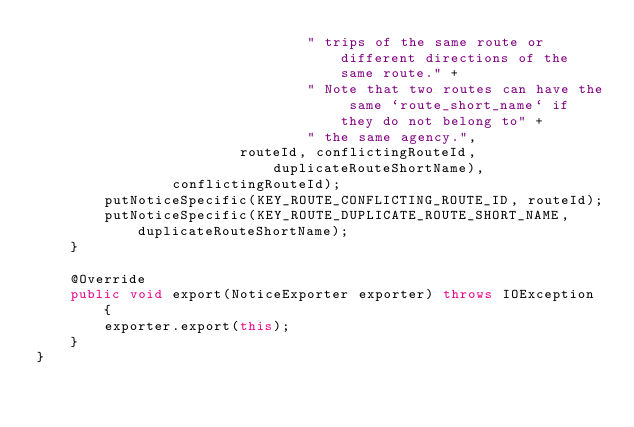Convert code to text. <code><loc_0><loc_0><loc_500><loc_500><_Java_>                                " trips of the same route or different directions of the same route." +
                                " Note that two routes can have the same `route_short_name` if they do not belong to" +
                                " the same agency.",
                        routeId, conflictingRouteId, duplicateRouteShortName),
                conflictingRouteId);
        putNoticeSpecific(KEY_ROUTE_CONFLICTING_ROUTE_ID, routeId);
        putNoticeSpecific(KEY_ROUTE_DUPLICATE_ROUTE_SHORT_NAME, duplicateRouteShortName);
    }

    @Override
    public void export(NoticeExporter exporter) throws IOException {
        exporter.export(this);
    }
}
</code> 